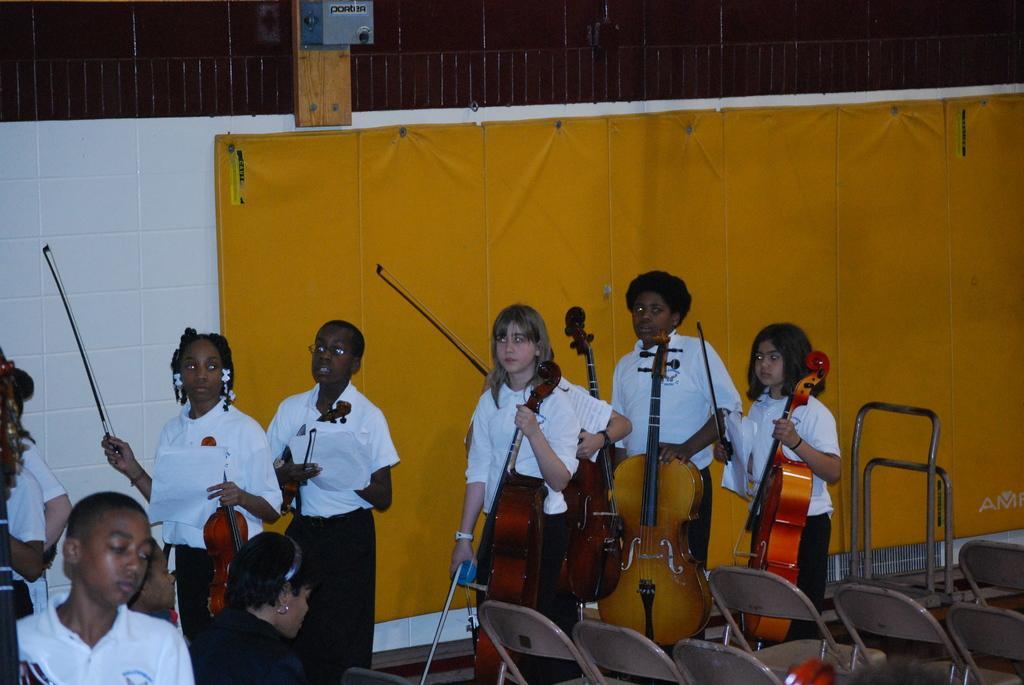Who or what can be seen in the image? There are people in the image. What are the people doing in the image? The people are standing and holding musical instruments. Are there any objects related to seating in the image? Yes, there are chairs in the image. What type of design can be seen on the bomb in the image? There is no bomb present in the image; it features people standing and holding musical instruments. Can you hear the whistle of the wind in the image? The image is a still picture and does not convey sound, so it is impossible to hear any whistling in the image. 